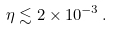Convert formula to latex. <formula><loc_0><loc_0><loc_500><loc_500>\eta \lesssim 2 \times 1 0 ^ { - 3 } \, .</formula> 